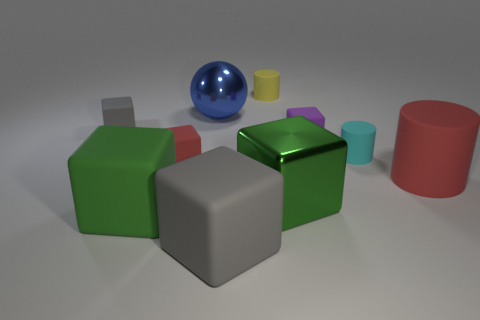Subtract all tiny matte cylinders. How many cylinders are left? 1 Subtract all cyan cylinders. How many cylinders are left? 2 Subtract all balls. How many objects are left? 9 Subtract 2 cubes. How many cubes are left? 4 Subtract all blue cylinders. Subtract all purple balls. How many cylinders are left? 3 Subtract all blue balls. How many purple cylinders are left? 0 Subtract all metallic spheres. Subtract all tiny cyan cylinders. How many objects are left? 8 Add 3 small matte cylinders. How many small matte cylinders are left? 5 Add 7 tiny gray rubber cubes. How many tiny gray rubber cubes exist? 8 Subtract 0 brown cubes. How many objects are left? 10 